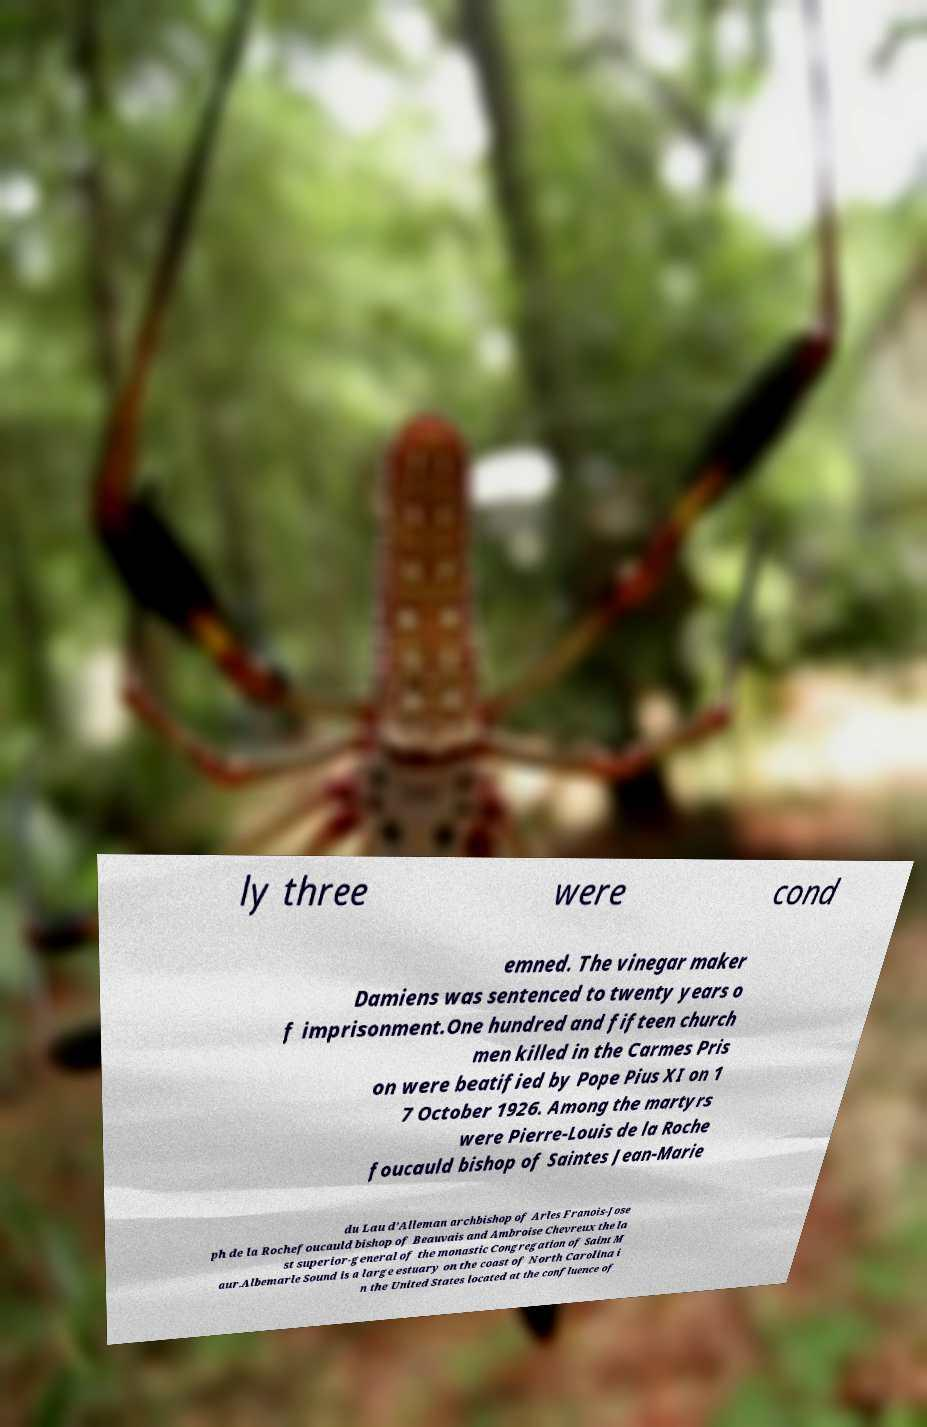For documentation purposes, I need the text within this image transcribed. Could you provide that? ly three were cond emned. The vinegar maker Damiens was sentenced to twenty years o f imprisonment.One hundred and fifteen church men killed in the Carmes Pris on were beatified by Pope Pius XI on 1 7 October 1926. Among the martyrs were Pierre-Louis de la Roche foucauld bishop of Saintes Jean-Marie du Lau d’Alleman archbishop of Arles Franois-Jose ph de la Rochefoucauld bishop of Beauvais and Ambroise Chevreux the la st superior-general of the monastic Congregation of Saint M aur.Albemarle Sound is a large estuary on the coast of North Carolina i n the United States located at the confluence of 